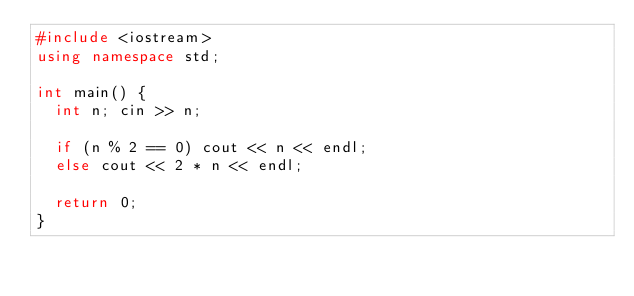<code> <loc_0><loc_0><loc_500><loc_500><_C++_>#include <iostream>
using namespace std;

int main() {
	int n; cin >> n;

	if (n % 2 == 0) cout << n << endl;
	else cout << 2 * n << endl;

	return 0;
}</code> 